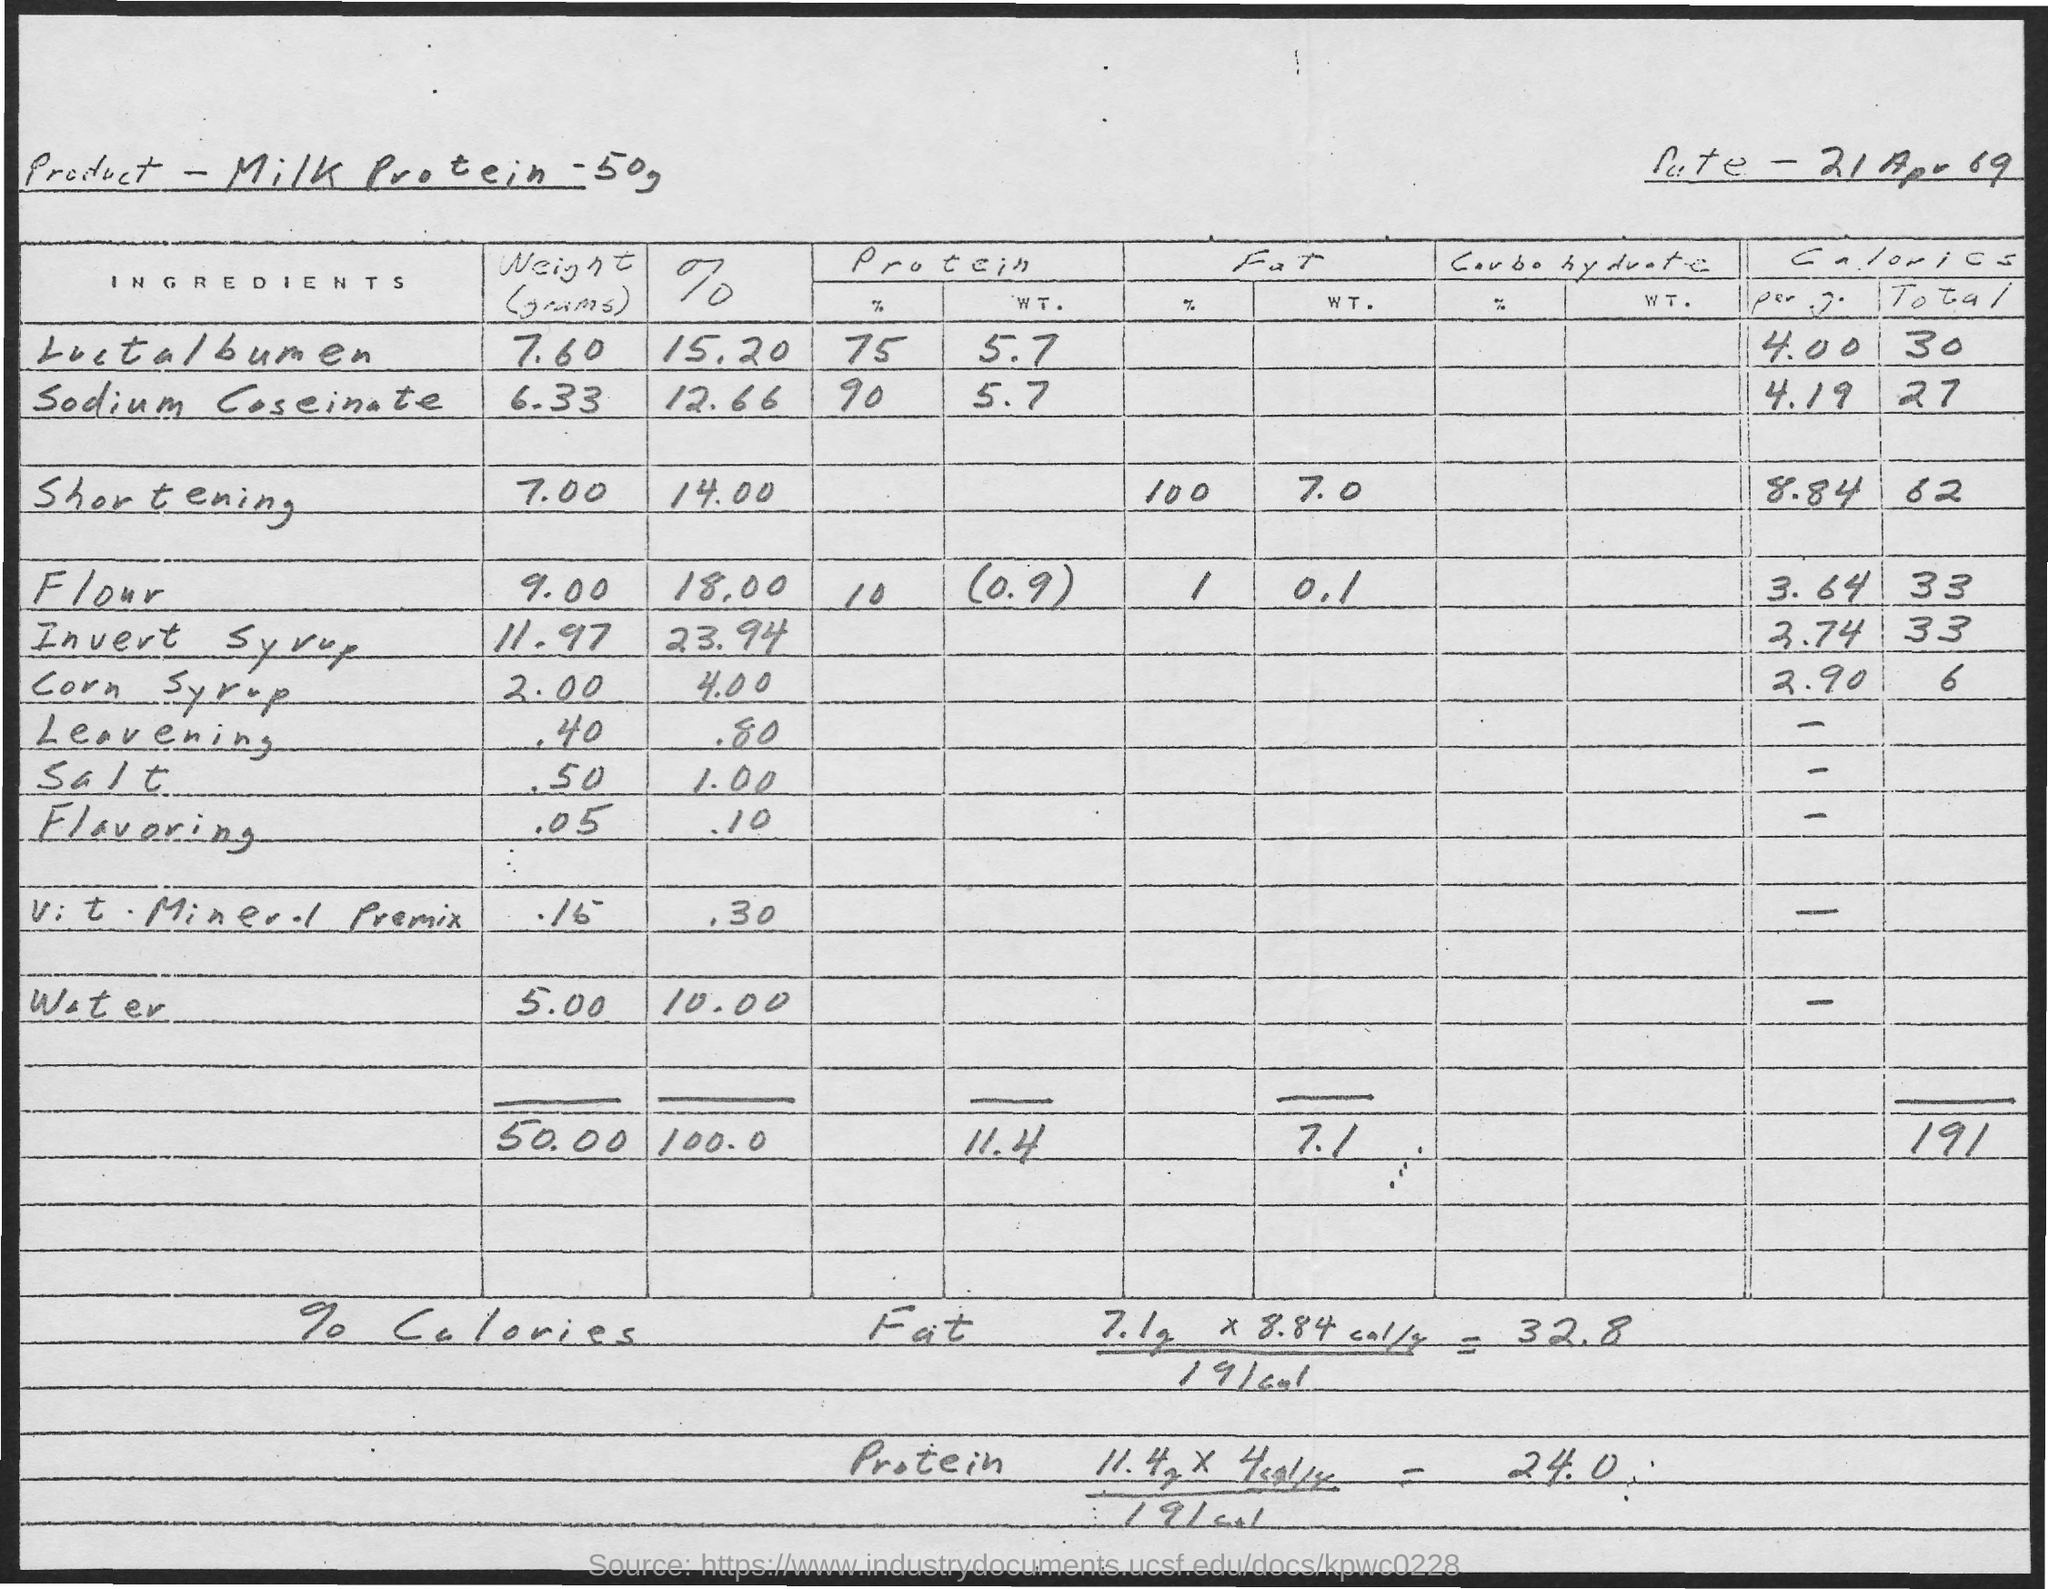What is the name of the product?
Keep it short and to the point. Milk protein -50g. What is the weight of corn syrup?
Offer a terse response. 2.00. What is the percentage of salt in the product?
Offer a terse response. 1.00. 